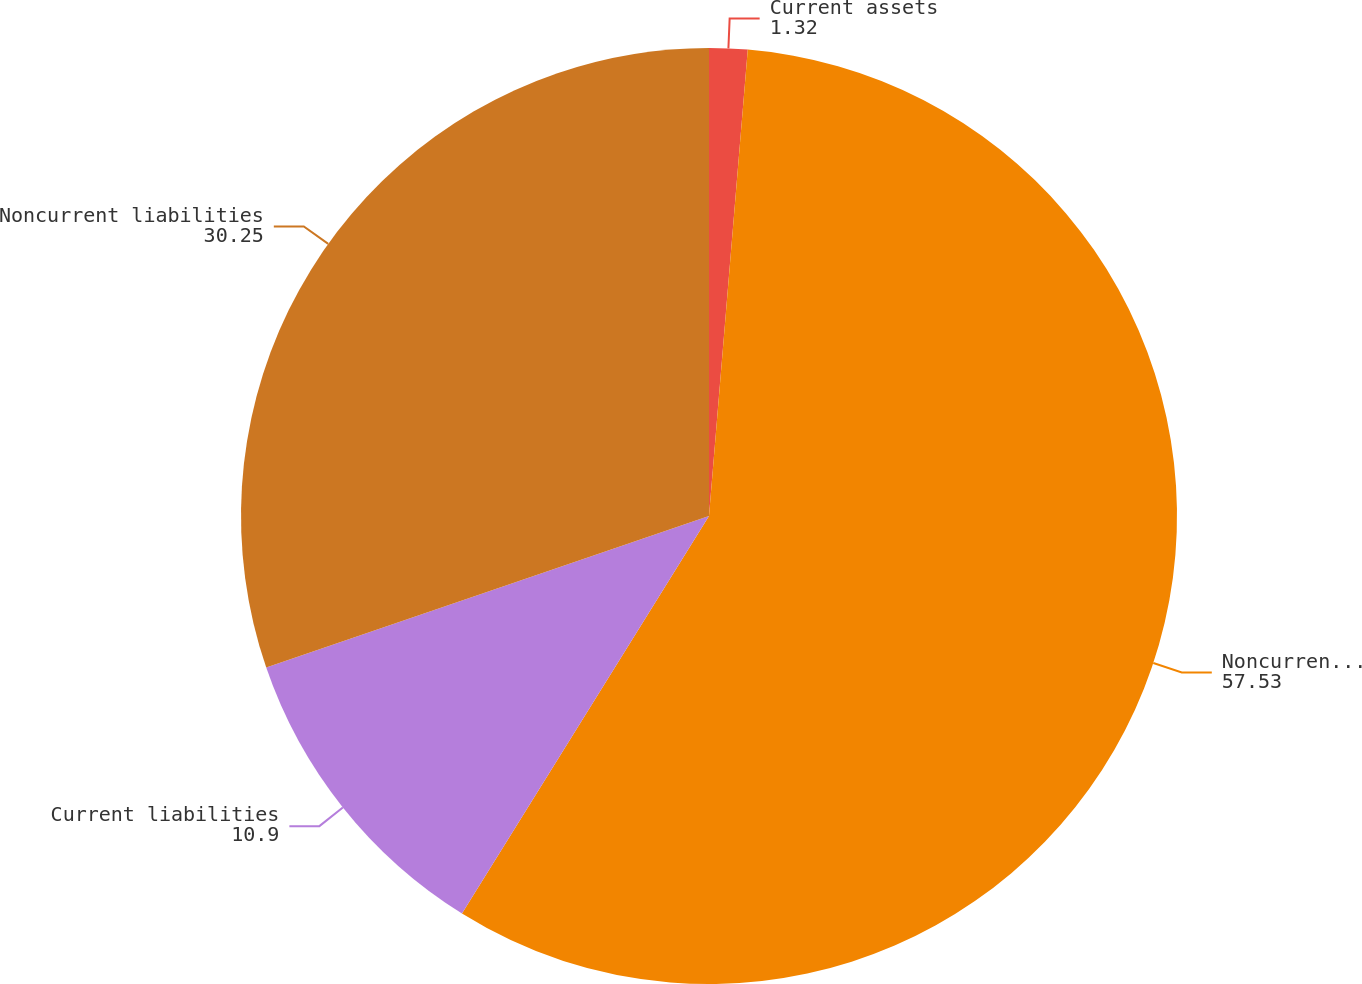Convert chart. <chart><loc_0><loc_0><loc_500><loc_500><pie_chart><fcel>Current assets<fcel>Noncurrent assets<fcel>Current liabilities<fcel>Noncurrent liabilities<nl><fcel>1.32%<fcel>57.53%<fcel>10.9%<fcel>30.25%<nl></chart> 